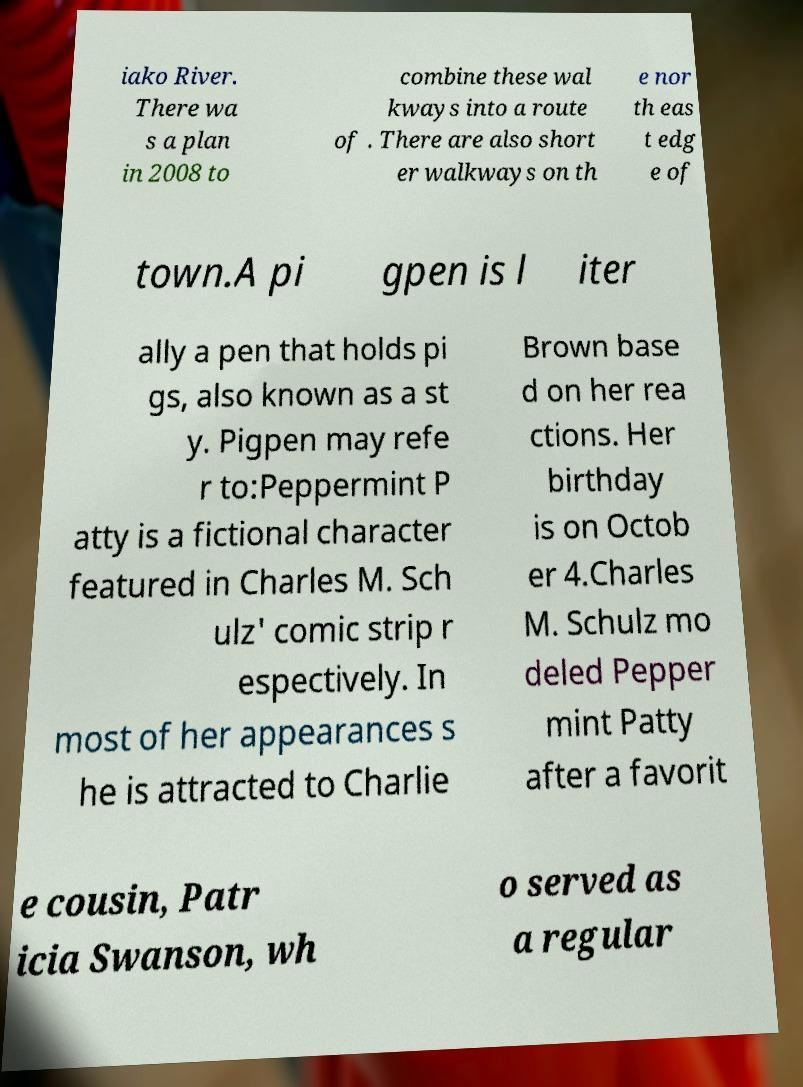Can you read and provide the text displayed in the image?This photo seems to have some interesting text. Can you extract and type it out for me? iako River. There wa s a plan in 2008 to combine these wal kways into a route of . There are also short er walkways on th e nor th eas t edg e of town.A pi gpen is l iter ally a pen that holds pi gs, also known as a st y. Pigpen may refe r to:Peppermint P atty is a fictional character featured in Charles M. Sch ulz' comic strip r espectively. In most of her appearances s he is attracted to Charlie Brown base d on her rea ctions. Her birthday is on Octob er 4.Charles M. Schulz mo deled Pepper mint Patty after a favorit e cousin, Patr icia Swanson, wh o served as a regular 